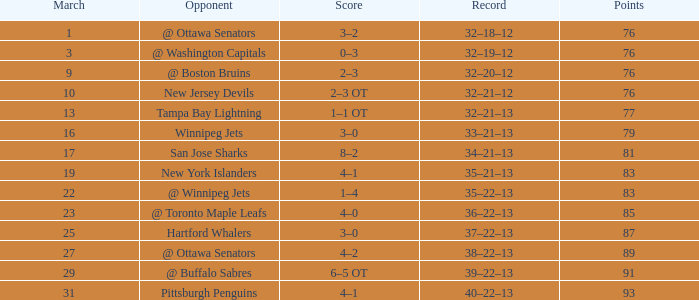I'm looking to parse the entire table for insights. Could you assist me with that? {'header': ['March', 'Opponent', 'Score', 'Record', 'Points'], 'rows': [['1', '@ Ottawa Senators', '3–2', '32–18–12', '76'], ['3', '@ Washington Capitals', '0–3', '32–19–12', '76'], ['9', '@ Boston Bruins', '2–3', '32–20–12', '76'], ['10', 'New Jersey Devils', '2–3 OT', '32–21–12', '76'], ['13', 'Tampa Bay Lightning', '1–1 OT', '32–21–13', '77'], ['16', 'Winnipeg Jets', '3–0', '33–21–13', '79'], ['17', 'San Jose Sharks', '8–2', '34–21–13', '81'], ['19', 'New York Islanders', '4–1', '35–21–13', '83'], ['22', '@ Winnipeg Jets', '1–4', '35–22–13', '83'], ['23', '@ Toronto Maple Leafs', '4–0', '36–22–13', '85'], ['25', 'Hartford Whalers', '3–0', '37–22–13', '87'], ['27', '@ Ottawa Senators', '4–2', '38–22–13', '89'], ['29', '@ Buffalo Sabres', '6–5 OT', '39–22–13', '91'], ['31', 'Pittsburgh Penguins', '4–1', '40–22–13', '93']]} What is the quantity of points for march if it amounts to 85 points? 1.0. 